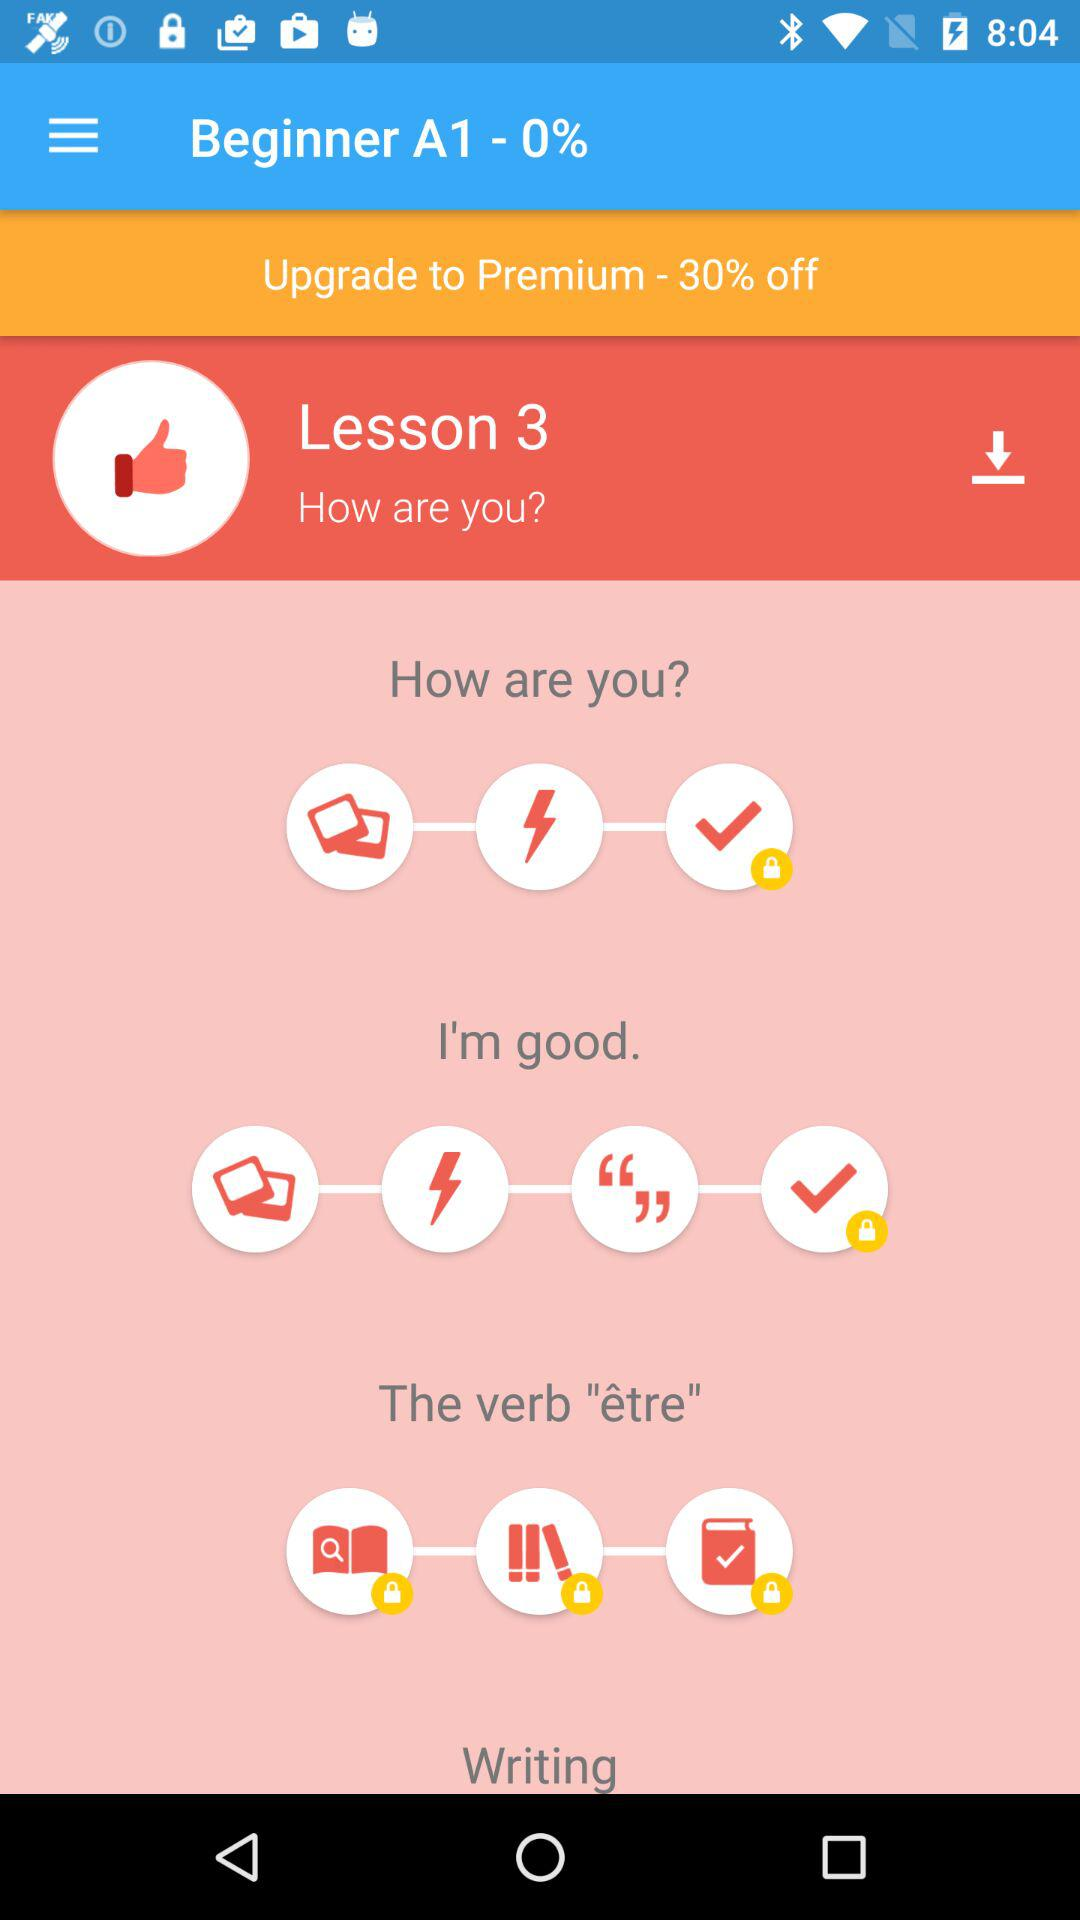How many lessons are there in total?
Answer the question using a single word or phrase. 3 